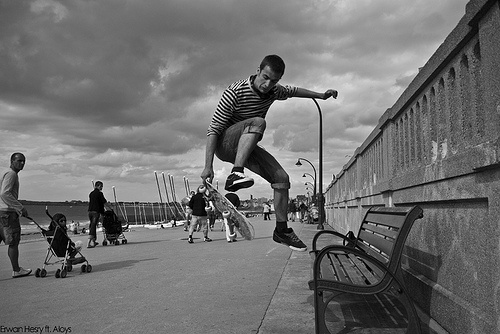Describe the objects in this image and their specific colors. I can see bench in gray, black, and lightgray tones, people in gray, black, darkgray, and lightgray tones, people in black and gray tones, skateboard in gray, black, darkgray, and lightgray tones, and people in gray, black, darkgray, and lightgray tones in this image. 